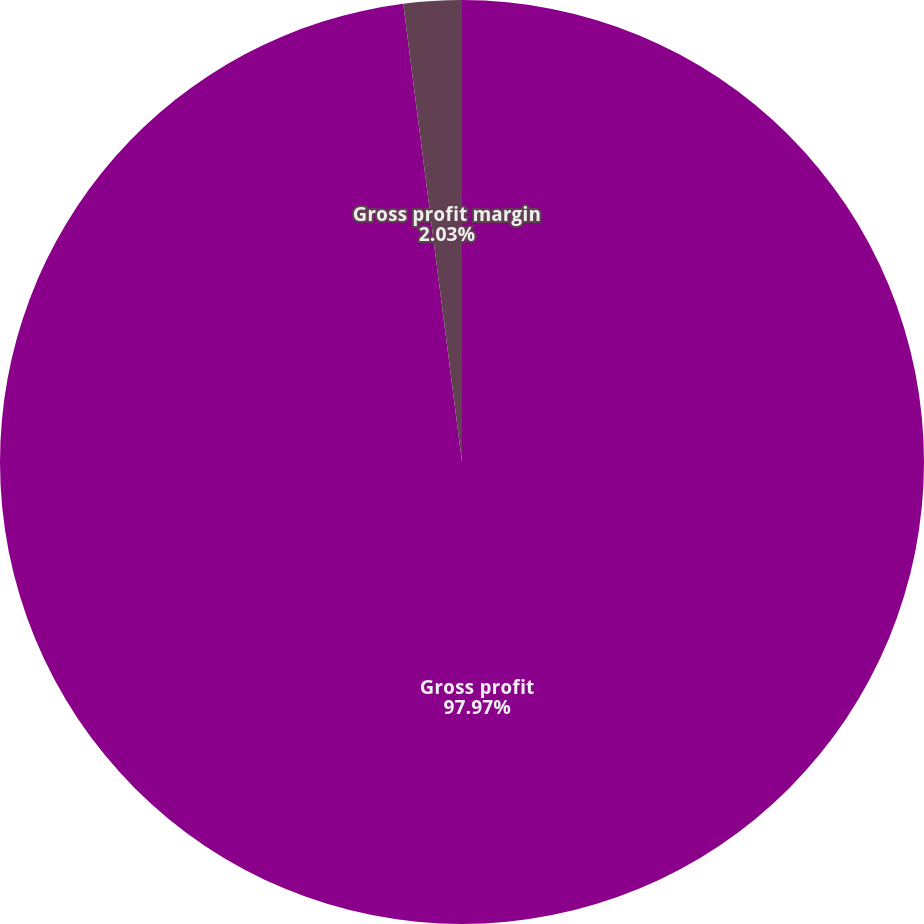Convert chart to OTSL. <chart><loc_0><loc_0><loc_500><loc_500><pie_chart><fcel>Gross profit<fcel>Gross profit margin<nl><fcel>97.97%<fcel>2.03%<nl></chart> 